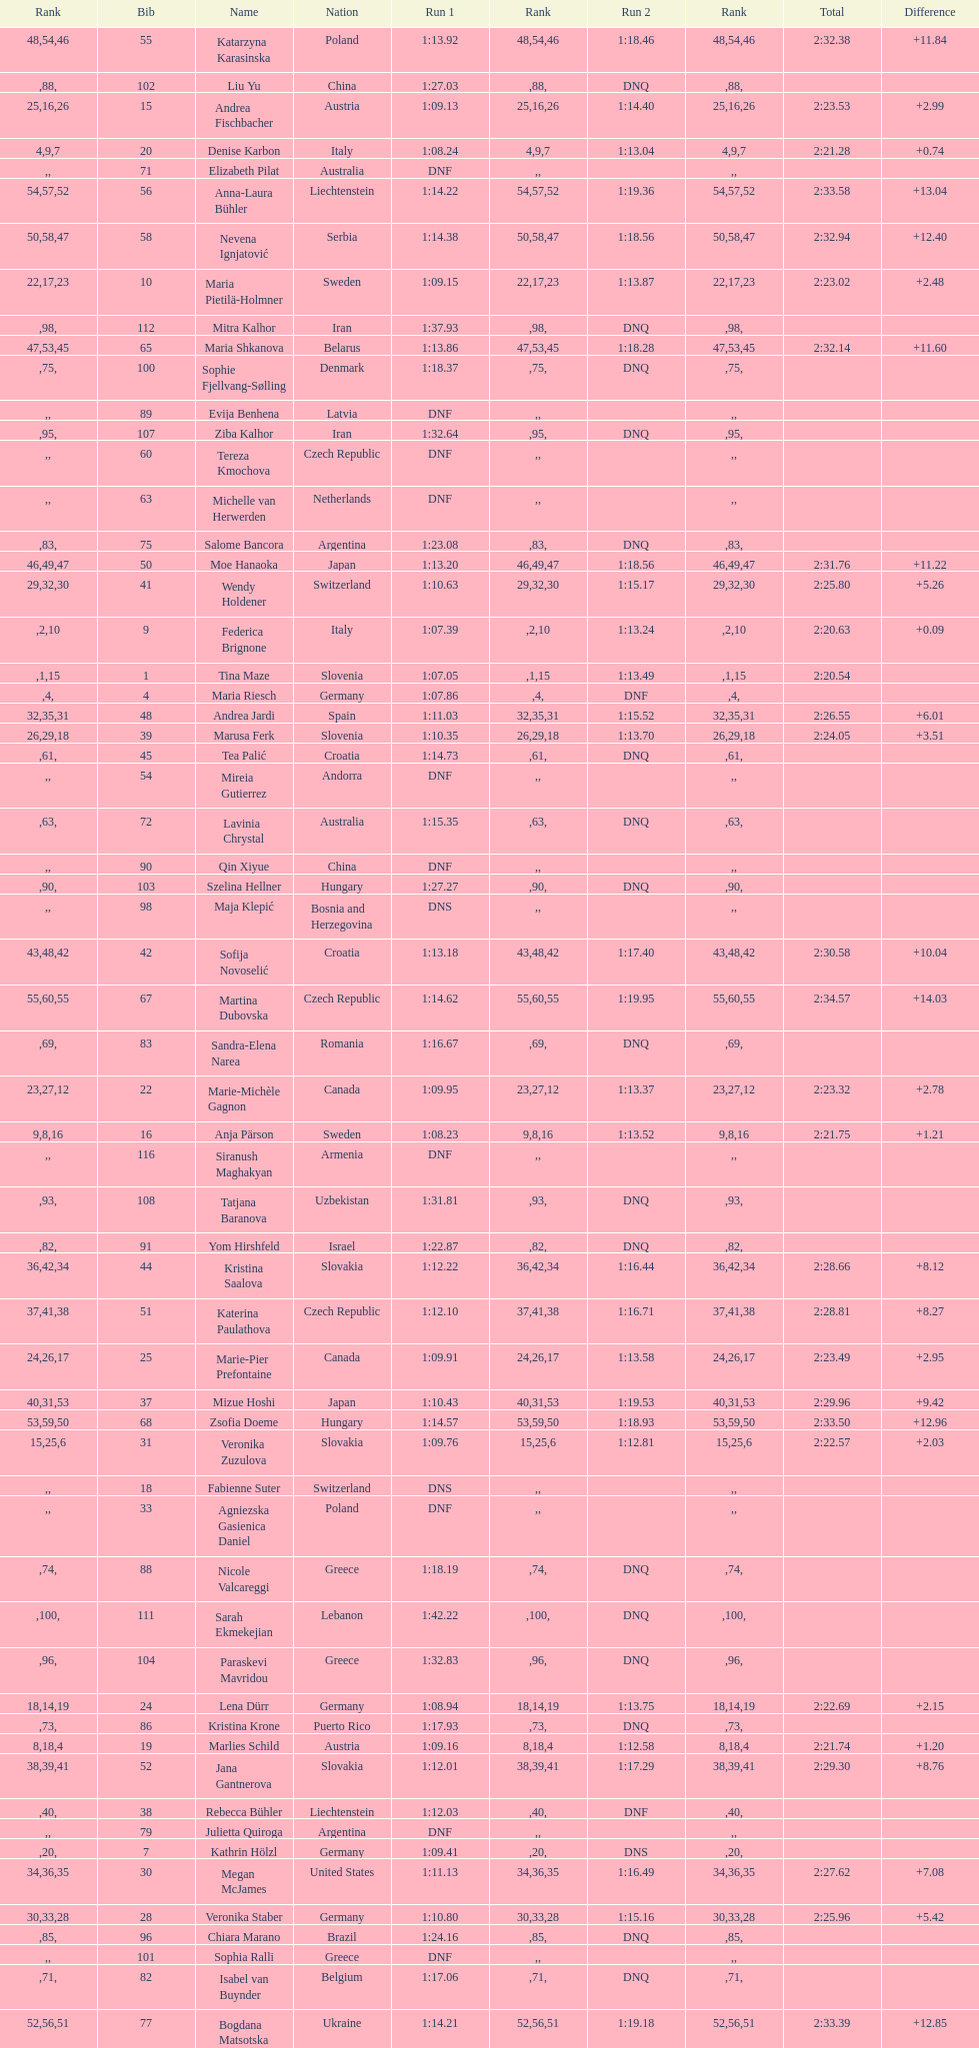Who finished next after federica brignone? Tessa Worley. 